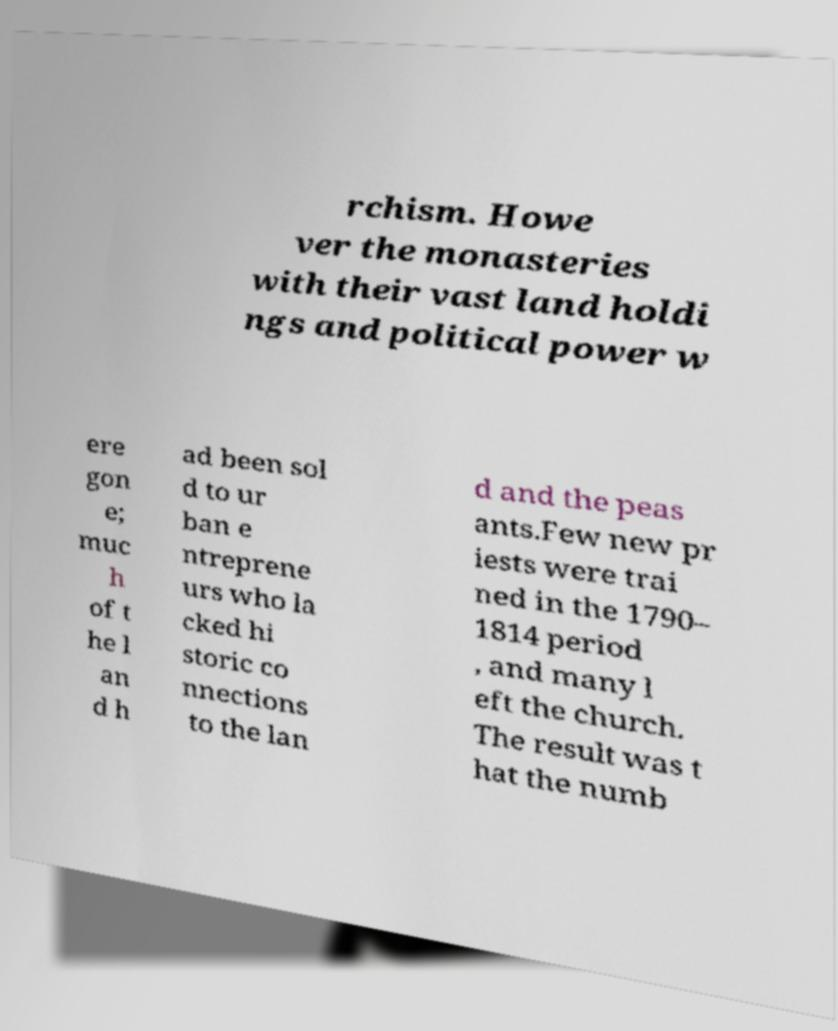Can you read and provide the text displayed in the image?This photo seems to have some interesting text. Can you extract and type it out for me? rchism. Howe ver the monasteries with their vast land holdi ngs and political power w ere gon e; muc h of t he l an d h ad been sol d to ur ban e ntreprene urs who la cked hi storic co nnections to the lan d and the peas ants.Few new pr iests were trai ned in the 1790– 1814 period , and many l eft the church. The result was t hat the numb 